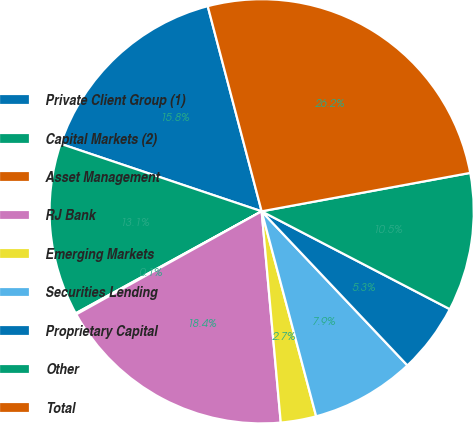Convert chart. <chart><loc_0><loc_0><loc_500><loc_500><pie_chart><fcel>Private Client Group (1)<fcel>Capital Markets (2)<fcel>Asset Management<fcel>RJ Bank<fcel>Emerging Markets<fcel>Securities Lending<fcel>Proprietary Capital<fcel>Other<fcel>Total<nl><fcel>15.75%<fcel>13.14%<fcel>0.09%<fcel>18.36%<fcel>2.7%<fcel>7.92%<fcel>5.31%<fcel>10.53%<fcel>26.19%<nl></chart> 